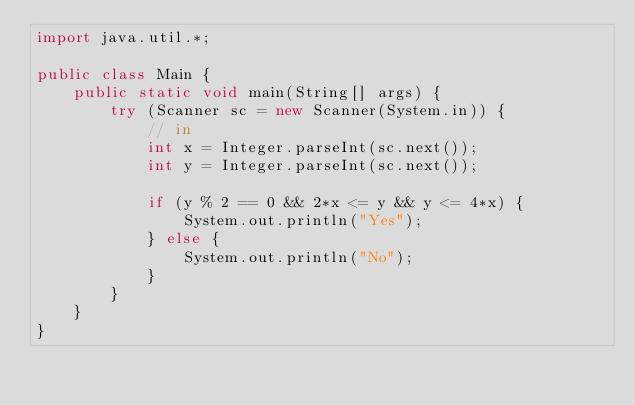<code> <loc_0><loc_0><loc_500><loc_500><_Java_>import java.util.*;

public class Main {
    public static void main(String[] args) {
        try (Scanner sc = new Scanner(System.in)) {
            // in
            int x = Integer.parseInt(sc.next());
            int y = Integer.parseInt(sc.next());

            if (y % 2 == 0 && 2*x <= y && y <= 4*x) {
                System.out.println("Yes");
            } else {
                System.out.println("No");
            }
        }
    }
}
</code> 